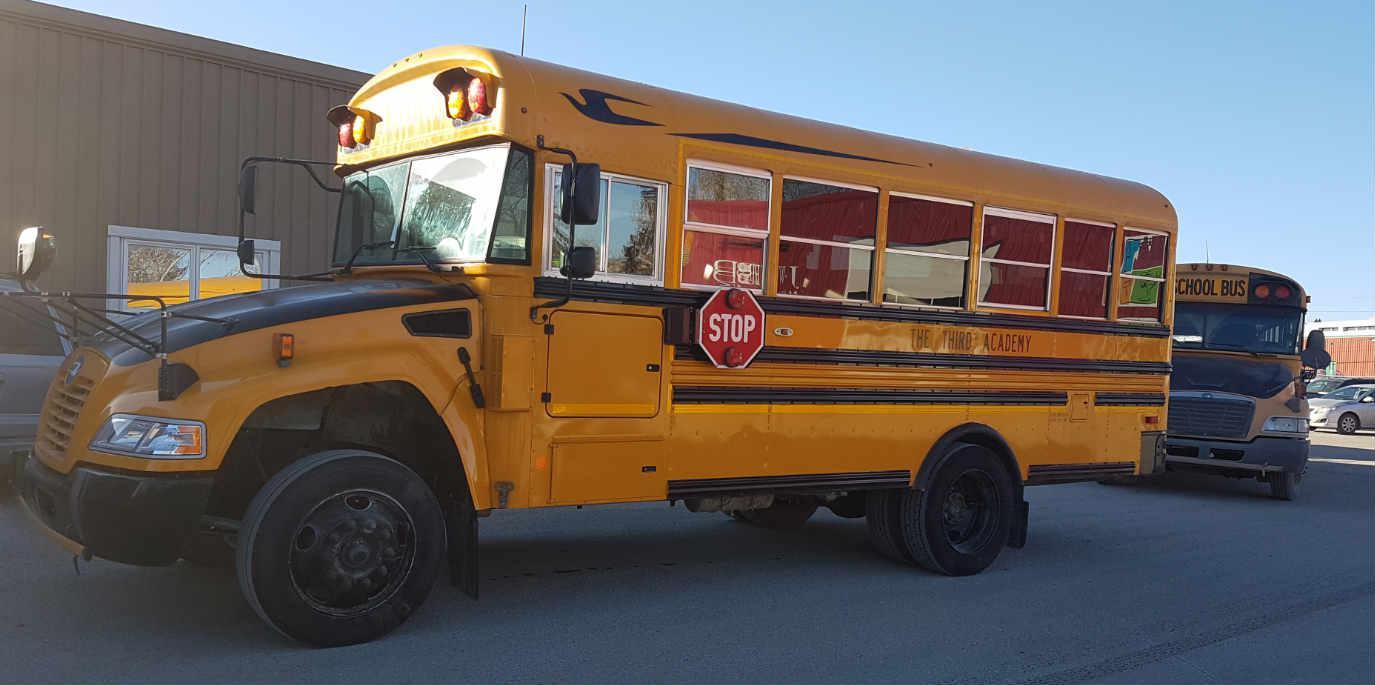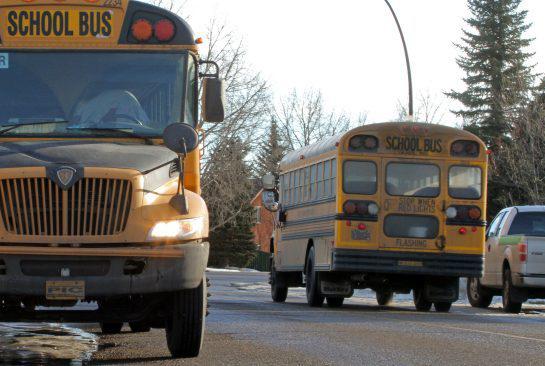The first image is the image on the left, the second image is the image on the right. For the images shown, is this caption "One of the images shows a school bus that has had an accident." true? Answer yes or no. No. The first image is the image on the left, the second image is the image on the right. Assess this claim about the two images: "There are two buses going in opposite directions.". Correct or not? Answer yes or no. Yes. 